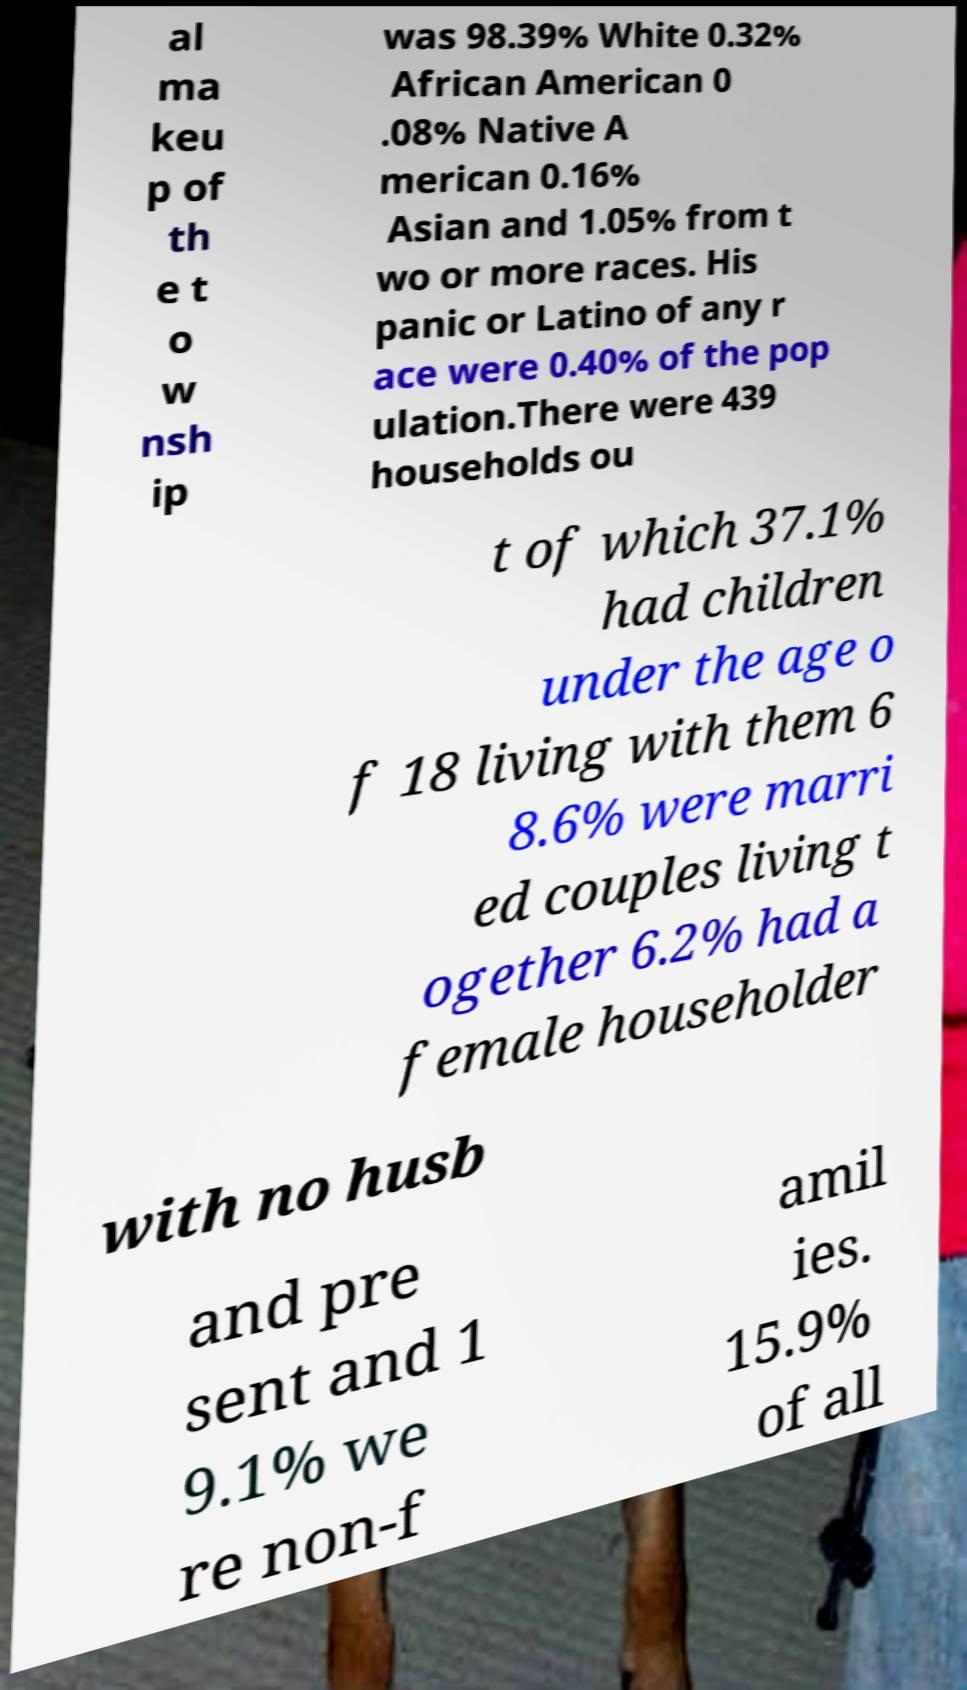For documentation purposes, I need the text within this image transcribed. Could you provide that? al ma keu p of th e t o w nsh ip was 98.39% White 0.32% African American 0 .08% Native A merican 0.16% Asian and 1.05% from t wo or more races. His panic or Latino of any r ace were 0.40% of the pop ulation.There were 439 households ou t of which 37.1% had children under the age o f 18 living with them 6 8.6% were marri ed couples living t ogether 6.2% had a female householder with no husb and pre sent and 1 9.1% we re non-f amil ies. 15.9% of all 